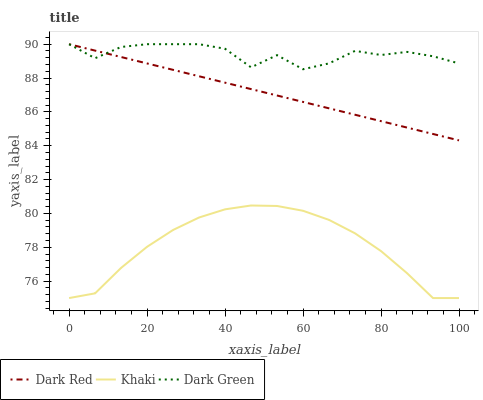Does Khaki have the minimum area under the curve?
Answer yes or no. Yes. Does Dark Green have the maximum area under the curve?
Answer yes or no. Yes. Does Dark Green have the minimum area under the curve?
Answer yes or no. No. Does Khaki have the maximum area under the curve?
Answer yes or no. No. Is Dark Red the smoothest?
Answer yes or no. Yes. Is Dark Green the roughest?
Answer yes or no. Yes. Is Khaki the smoothest?
Answer yes or no. No. Is Khaki the roughest?
Answer yes or no. No. Does Dark Green have the lowest value?
Answer yes or no. No. Does Dark Green have the highest value?
Answer yes or no. Yes. Does Khaki have the highest value?
Answer yes or no. No. Is Khaki less than Dark Red?
Answer yes or no. Yes. Is Dark Red greater than Khaki?
Answer yes or no. Yes. Does Dark Red intersect Dark Green?
Answer yes or no. Yes. Is Dark Red less than Dark Green?
Answer yes or no. No. Is Dark Red greater than Dark Green?
Answer yes or no. No. Does Khaki intersect Dark Red?
Answer yes or no. No. 